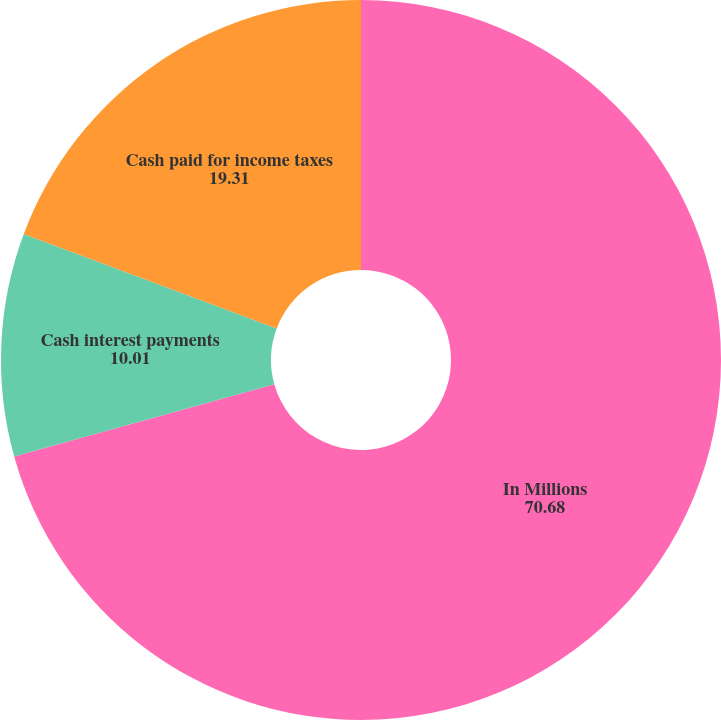Convert chart. <chart><loc_0><loc_0><loc_500><loc_500><pie_chart><fcel>In Millions<fcel>Cash interest payments<fcel>Cash paid for income taxes<nl><fcel>70.68%<fcel>10.01%<fcel>19.31%<nl></chart> 